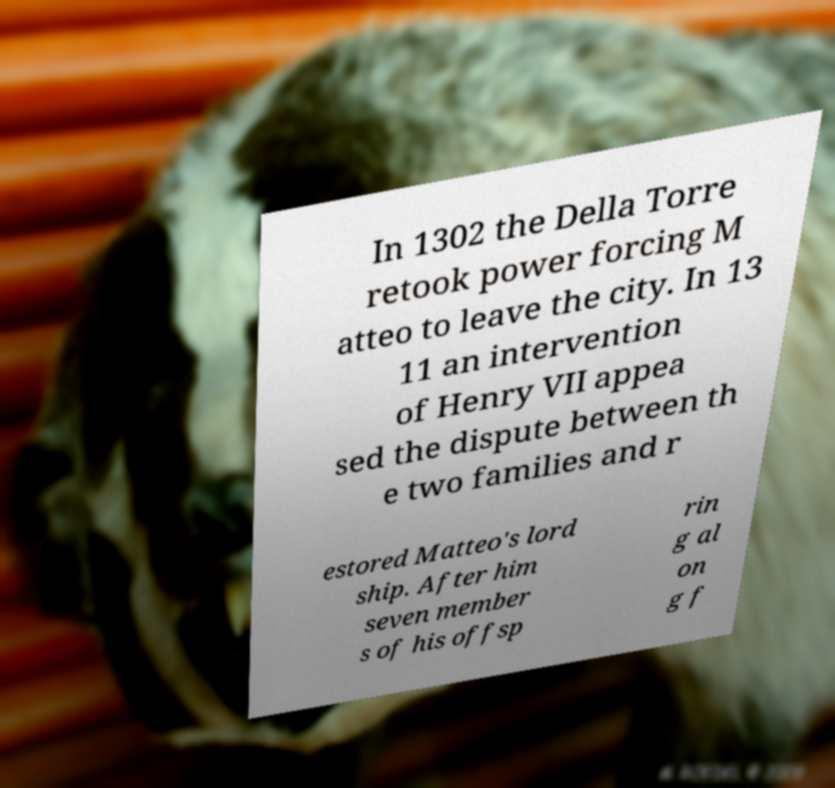Could you assist in decoding the text presented in this image and type it out clearly? In 1302 the Della Torre retook power forcing M atteo to leave the city. In 13 11 an intervention of Henry VII appea sed the dispute between th e two families and r estored Matteo's lord ship. After him seven member s of his offsp rin g al on g f 